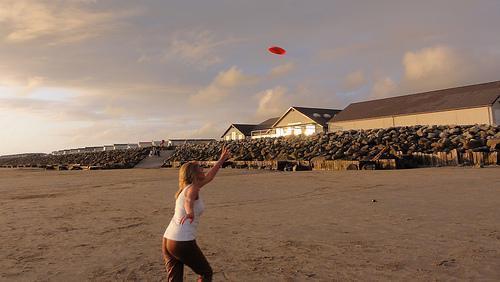How many people are in the photo?
Give a very brief answer. 1. 